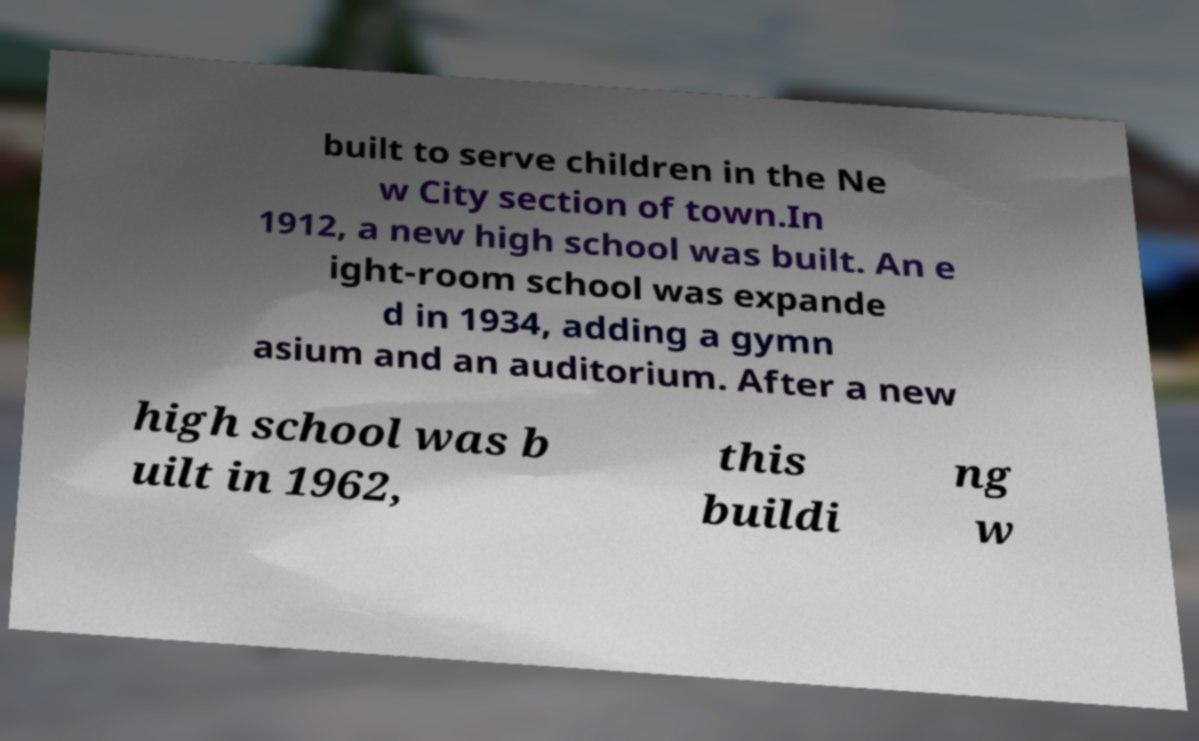I need the written content from this picture converted into text. Can you do that? built to serve children in the Ne w City section of town.In 1912, a new high school was built. An e ight-room school was expande d in 1934, adding a gymn asium and an auditorium. After a new high school was b uilt in 1962, this buildi ng w 